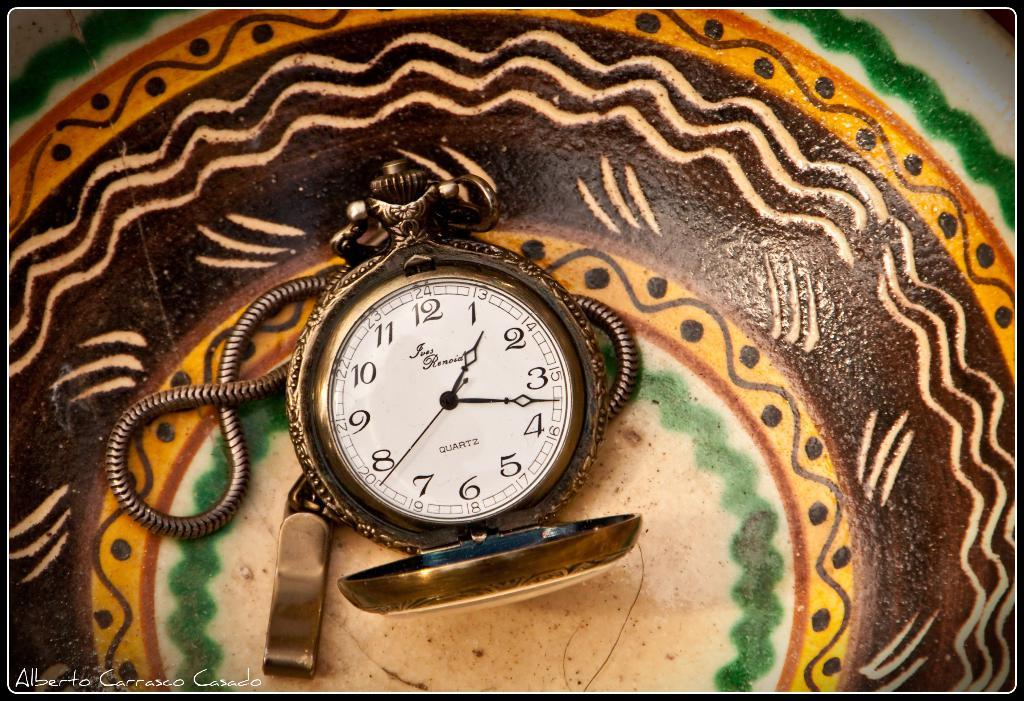<image>
Write a terse but informative summary of the picture. A picture of a clock that reads 1:17 was painted by a man named Alberto. 